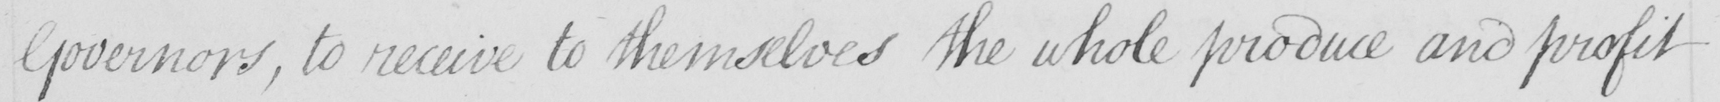What is written in this line of handwriting? Governors , to receive to themselves the whole produce and profit 